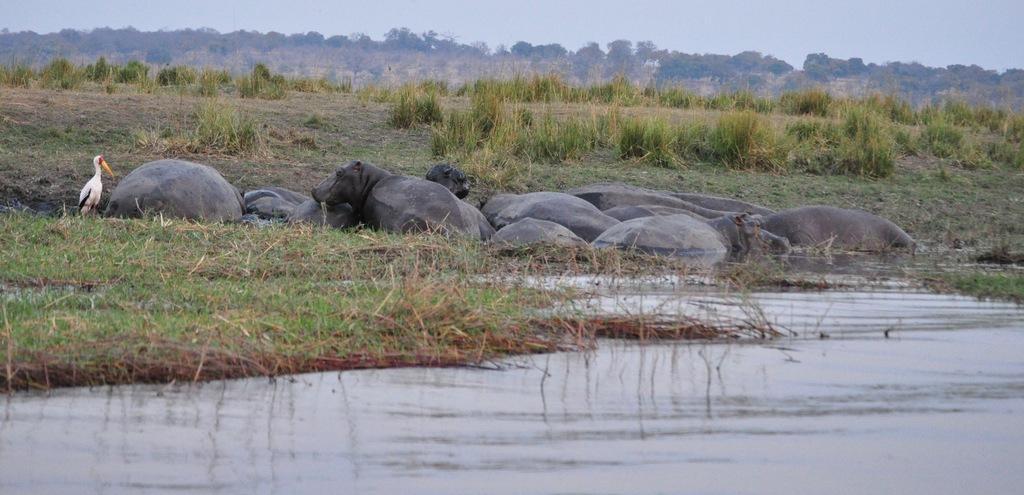Describe this image in one or two sentences. This is an outside view. At the bottom, I can see the water. In the middle of the image there are few animals in the water. On the left side there is a crane on the ground. In the background, I can see the grass and trees. At the top of the image I can see the sky. 